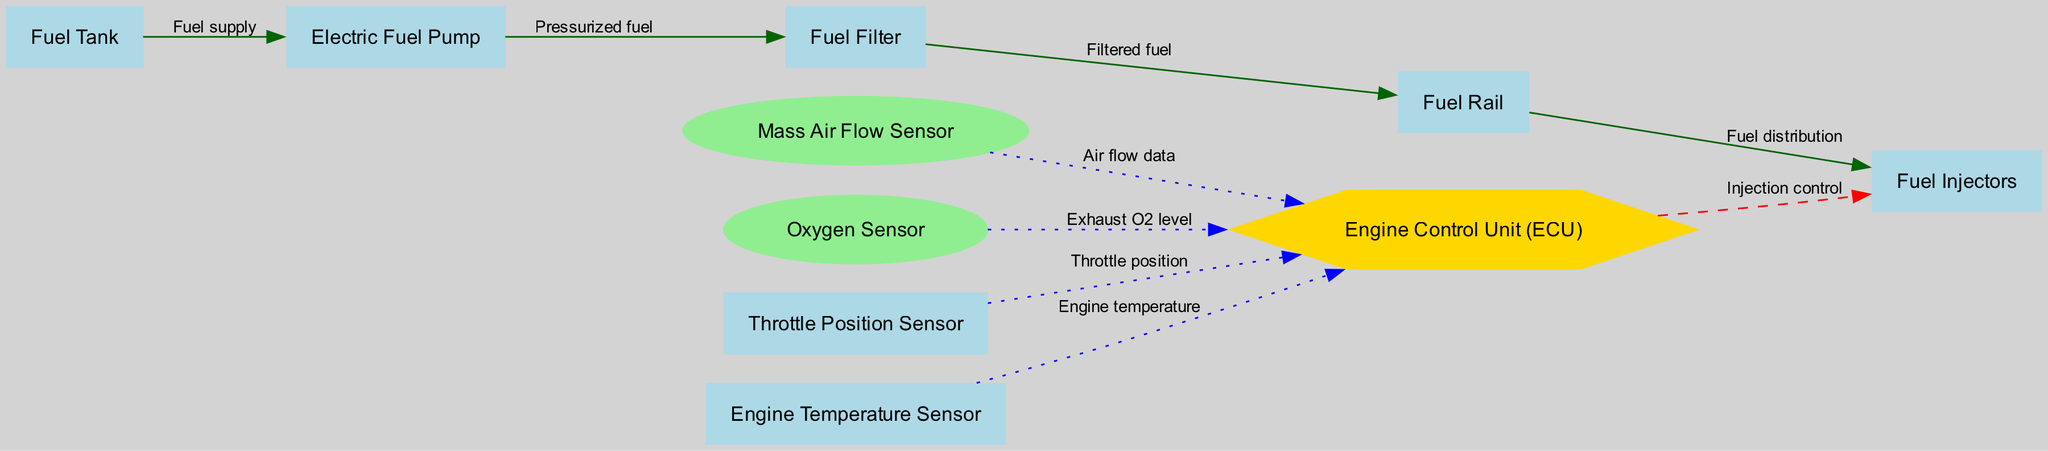What is the label of the node connected to the Fuel Tank? The node connected to the Fuel Tank is the Electric Fuel Pump, as indicated by the edge labeled "Fuel supply."
Answer: Electric Fuel Pump How many sensors are present in the diagram? There are four sensors present: Mass Air Flow Sensor, Oxygen Sensor, Throttle Position Sensor, and Engine Temperature Sensor.
Answer: Four Which node is responsible for controlling the Fuel Injectors? The Engine Control Unit (ECU) is responsible for controlling the Fuel Injectors, as shown by the edge labeled "Injection control" from ECU to Injectors.
Answer: Engine Control Unit What type of node is the Engine Control Unit (ECU)? The Engine Control Unit is represented as a hexagon in the diagram, which is a unique shape used for this node to denote its importance.
Answer: Hexagon What type of edge connects the Oxygen Sensor to the ECU? The edge connecting the Oxygen Sensor to the ECU is labeled as dotted and colored blue, indicating that it transmits Exhaust O2 level data.
Answer: Dotted Explain the flow of fuel from the Fuel Tank to the Injectors. The fuel flows from the Fuel Tank to the Electric Fuel Pump, which pressurizes it before sending it to the Fuel Filter. After being filtered, it moves to the Fuel Rail, from which it is distributed to the Fuel Injectors for injection into the combustion chamber.
Answer: Fuel Tank → Electric Fuel Pump → Fuel Filter → Fuel Rail → Fuel Injectors What is the purpose of the Throttle Position Sensor in the diagram? The Throttle Position Sensor provides data on the current throttle position to the Engine Control Unit, allowing the ECU to adjust fuel injection accordingly for optimal engine performance.
Answer: Throttle position data How does the ECU receive information from multiple sensors? The ECU receives data from the Mass Air Flow Sensor, Oxygen Sensor, Throttle Position Sensor, and Engine Temperature Sensor via separate edges, each providing relevant information for fuel management and efficiency.
Answer: Through separate edges from each sensor 